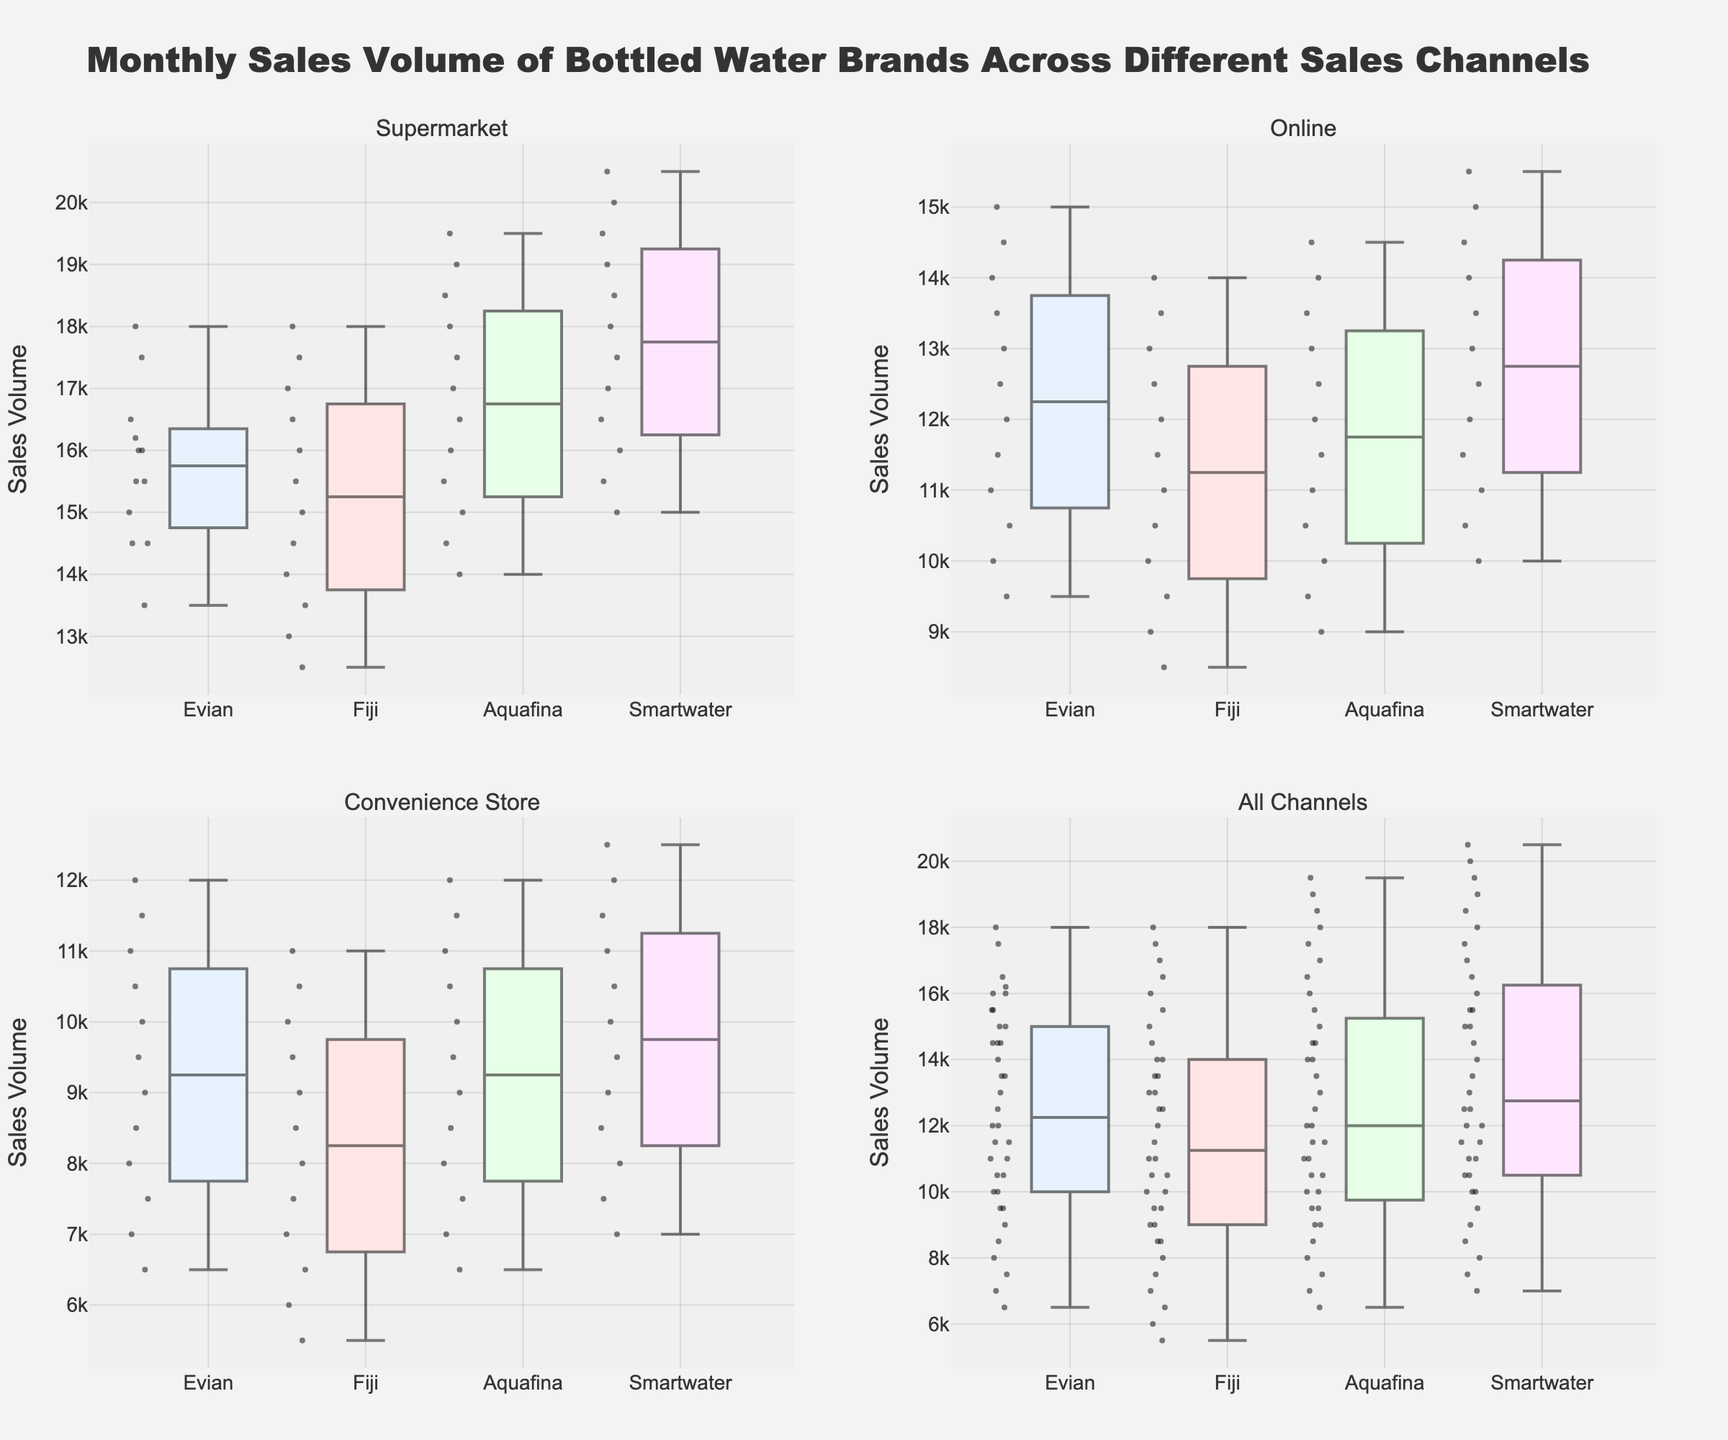What's the title of the figure? The title of the figure is usually found at the top and is clearly intended to describe the content of the figure. In this case, it says, "Monthly Sales Volume of Bottled Water Brands Across Different Sales Channels."
Answer: Monthly Sales Volume of Bottled Water Brands Across Different Sales Channels Which brand has the highest sales volume in supermarkets? By looking at the supermarket subplot, which is located in the top left, we can see the highest values of sales volumes for each brand. Smartwater has the highest upper whisker, reaching 20,500 units in December.
Answer: Smartwater How do Evian's sales volumes compare between the online and convenience store channels? To compare Evian's sales volumes between the online and convenience store channels, observe the respective subplots. Evian shows higher median and upper whisker values in the online channel than in the convenience store channel.
Answer: Higher in Online Which brand has the most consistent sales volume across all channels? Consistency can be inferred from the range and spread of the box plots. The brand with the smallest range between the first quartile and third quartile in the "All Channels" subplot likely has more consistent sales. Aquafina shows such characteristics across all channels.
Answer: Aquafina What is the median sales volume for Smartwater in the online channel? In the online channel subplot (top right), locate the median line inside the box for Smartwater. The median is around 13,000 units.
Answer: 13,000 units Which sales channel sees the highest median sales for any brand? Observe the median lines across all box plots in all subplots. In the Supermarket subplot, Smartwater has the highest median line at approximately 18,000 units.
Answer: Supermarket for Smartwater Compare the range of sales volumes for Fiji and Evian in the convenience store channel. Observing the box plots in the convenience store channel subplot (bottom left), we see that the interquartile range (IQR) for Fiji is wider than that for Evian, indicating a larger spread of sales volumes.
Answer: Fiji has a wider range Which brand has a higher variance in sales volume in the supermarket channel: Evian or Aquafina? Variance can be inferred from the spread of the data points. In the supermarket subplot (top left), Aquafina shows a wider spread (greater variance) compared to Evian, which exhibits a more narrow distribution.
Answer: Aquafina Are there any outliers in the sales volume data? If yes, for which brand and channel? Outliers in box plots are usually indicated by points outside the whiskers. In the subplots, there don't appear to be individual points far from the whiskers, suggesting minimal or no outliers in this dataset.
Answer: No outliers What is the total range of sales volumes for all brands across all channels? To find the total range, identify the minimum and maximum sales volumes across all box plots in the "All Channels" subplot (bottom right). The minimum is around 5,500 units (Fiji, Convenience Store), and the maximum is 20,500 units (Smartwater, Supermarket), giving a total range of 15,000 units.
Answer: 15,000 units 